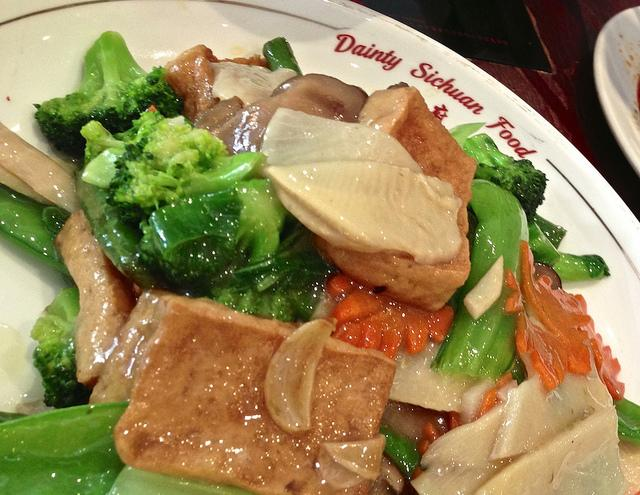What kind of cuisine is being served? sichuan 